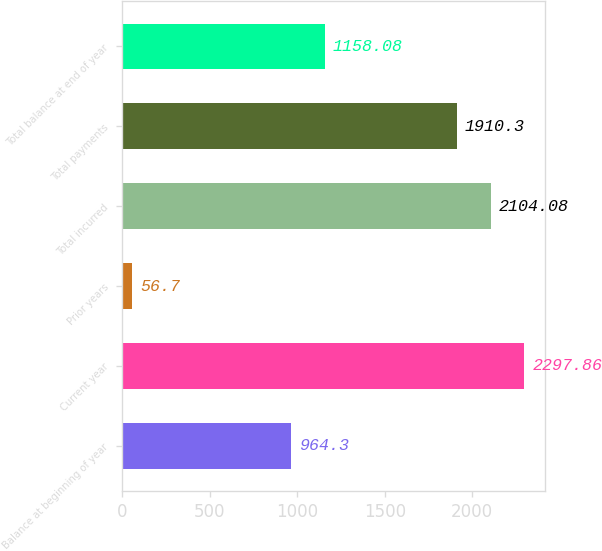<chart> <loc_0><loc_0><loc_500><loc_500><bar_chart><fcel>Balance at beginning of year<fcel>Current year<fcel>Prior years<fcel>Total incurred<fcel>Total payments<fcel>Total balance at end of year<nl><fcel>964.3<fcel>2297.86<fcel>56.7<fcel>2104.08<fcel>1910.3<fcel>1158.08<nl></chart> 